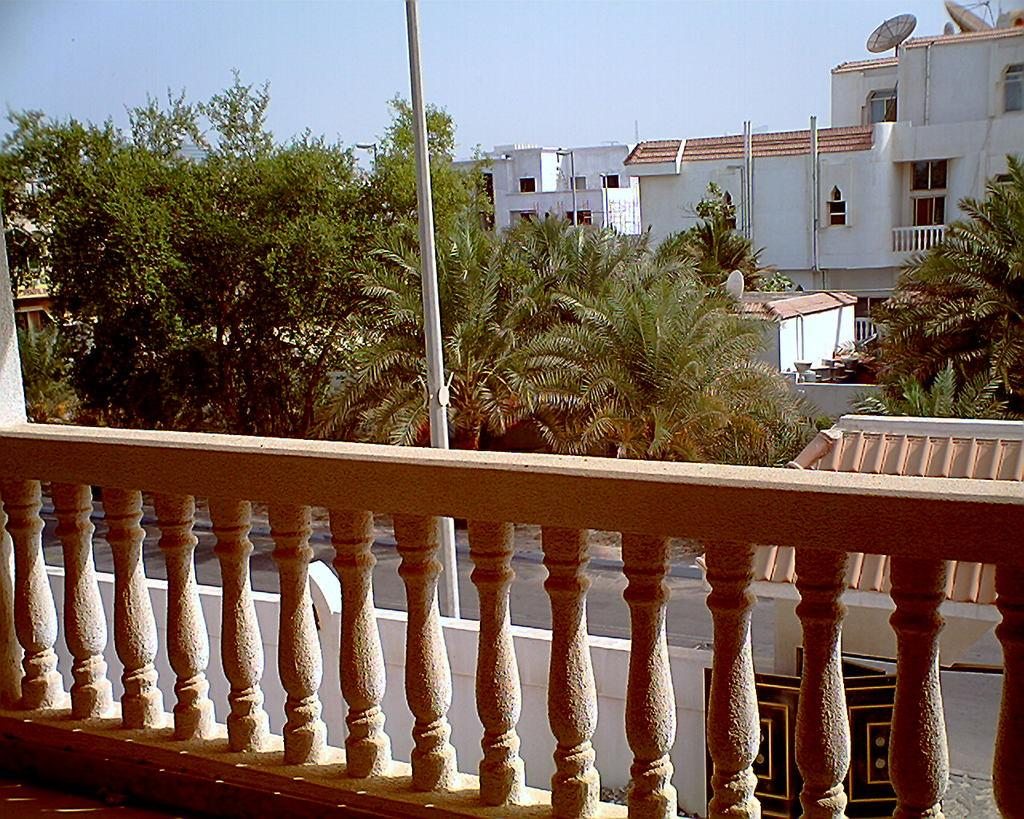What type of structure can be seen in the image? There is a railing in the image. What else is visible in the image besides the railing? There are buildings and trees in the image. What can be seen in the background of the image? The sky is visible in the background of the image. Where is the grandmother sitting on her throne in the image? There is no grandmother or throne present in the image. What type of tin is visible in the image? There is no tin present in the image. 